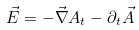Convert formula to latex. <formula><loc_0><loc_0><loc_500><loc_500>\vec { E } = - \vec { \nabla } A _ { t } - \partial _ { t } \vec { A }</formula> 